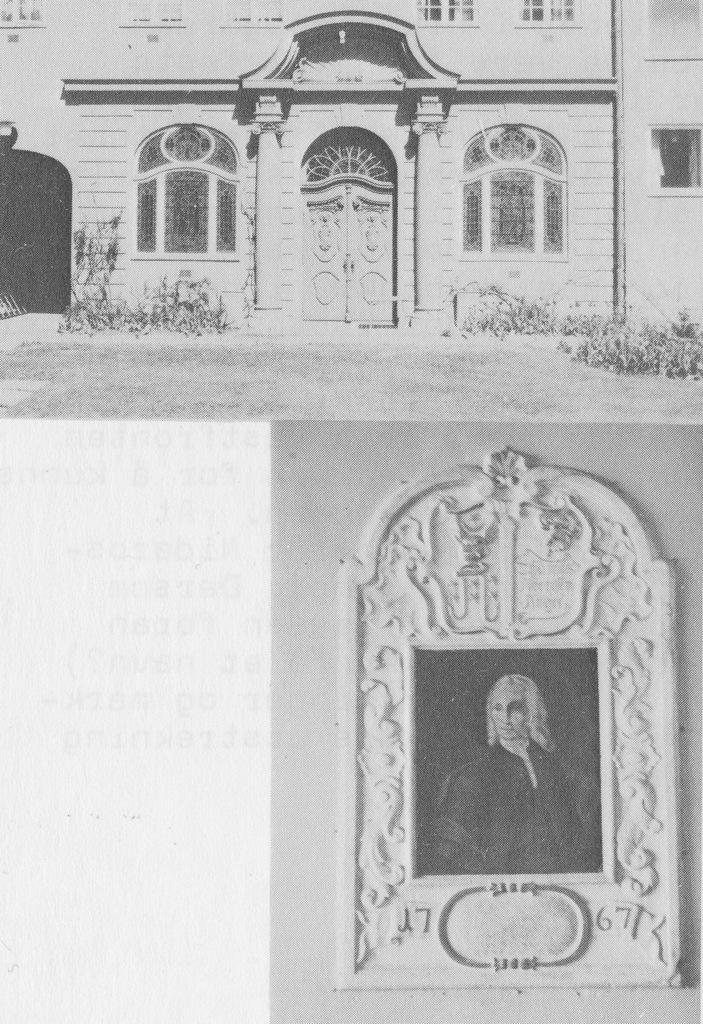What type of image is being described? The image is a collage. What can be seen at the top of the collage? There is a building depicted at the top of the image. What is attached to a wall at the bottom of the image? There is a photo frame attached to a wall at the bottom of the image. What type of feeling does the island in the image evoke? There is no island present in the image, so it cannot evoke any feelings. 